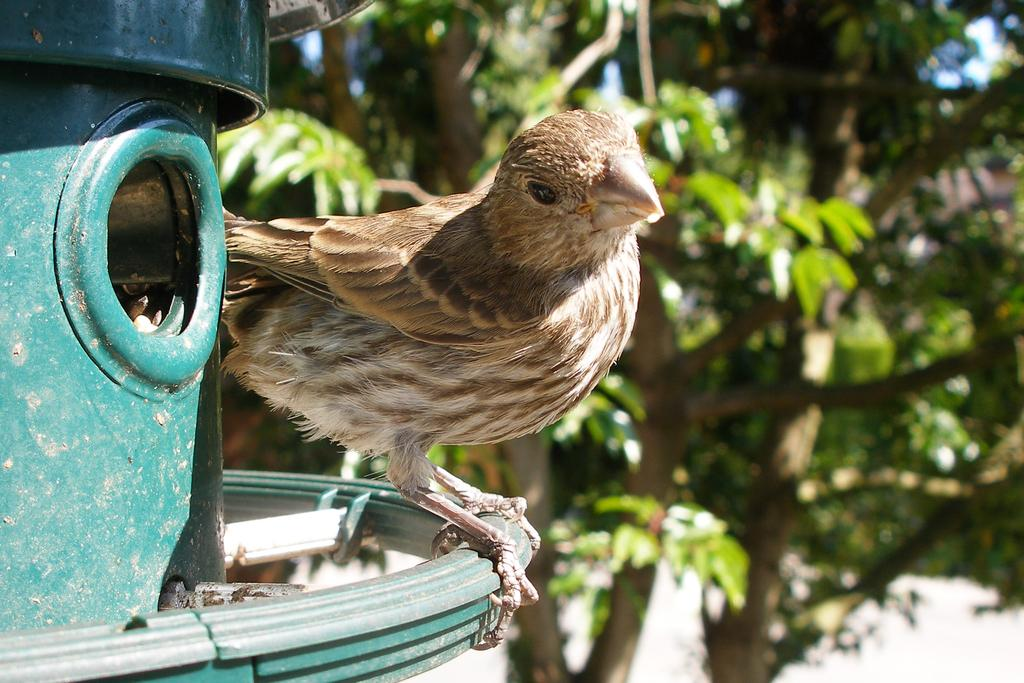What is on the pole in the image? There is a bird on a pole in the image. What type of vegetation can be seen in the image? There are trees visible on the side of the image. What color is the kite flying in the image? There is no kite present in the image. What type of cap is the bird wearing in the image? The bird is not wearing a cap in the image. 